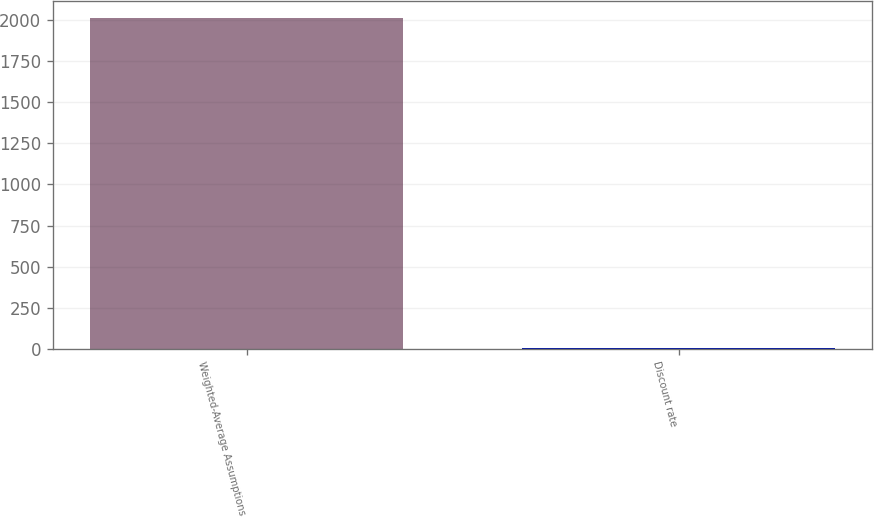<chart> <loc_0><loc_0><loc_500><loc_500><bar_chart><fcel>Weighted-Average Assumptions<fcel>Discount rate<nl><fcel>2017<fcel>3.71<nl></chart> 